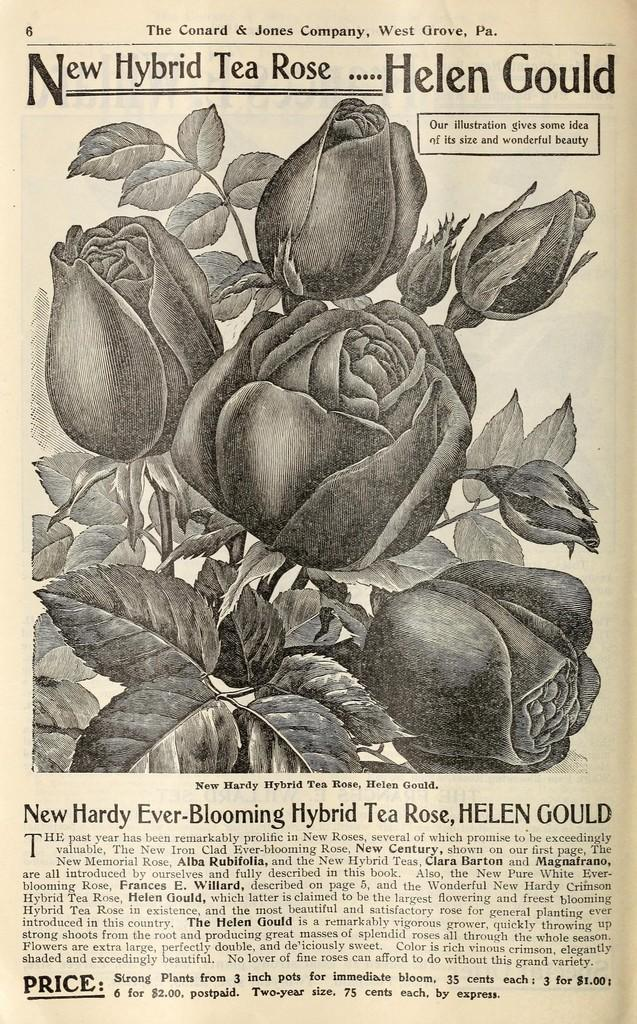What type of flowers are in the image? There are roses in the image. What else can be seen in the image besides the roses? There are leaves in the image. What is the paper with writing on it used for? The paper with writing on it is used for conveying information or messages. What color is the writing on the paper? The writing on the paper is in black color. Can you see any blood on the roses in the image? No, there is no blood present on the roses in the image. What type of friction is occurring between the leaves and the roses in the image? There is no information about friction between the leaves and roses in the image, as it is not mentioned in the provided facts. 